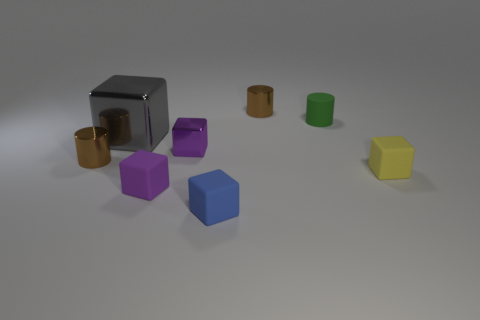What number of matte things are big blocks or big purple objects?
Keep it short and to the point. 0. What is the color of the object that is on the right side of the purple matte object and on the left side of the blue cube?
Offer a terse response. Purple. There is a brown shiny cylinder that is to the left of the gray metallic cube; is its size the same as the tiny yellow thing?
Make the answer very short. Yes. How many objects are either purple metallic blocks behind the yellow matte cube or small brown blocks?
Your answer should be very brief. 1. Is there a cyan rubber ball that has the same size as the green cylinder?
Keep it short and to the point. No. What material is the blue object that is the same size as the yellow rubber block?
Keep it short and to the point. Rubber. There is a tiny shiny thing that is in front of the green rubber thing and to the right of the gray metallic object; what shape is it?
Ensure brevity in your answer.  Cube. The matte cube in front of the small purple matte block is what color?
Keep it short and to the point. Blue. There is a thing that is right of the tiny purple metal thing and in front of the yellow block; how big is it?
Provide a succinct answer. Small. Is the material of the tiny yellow block the same as the small brown thing that is to the right of the blue block?
Your response must be concise. No. 